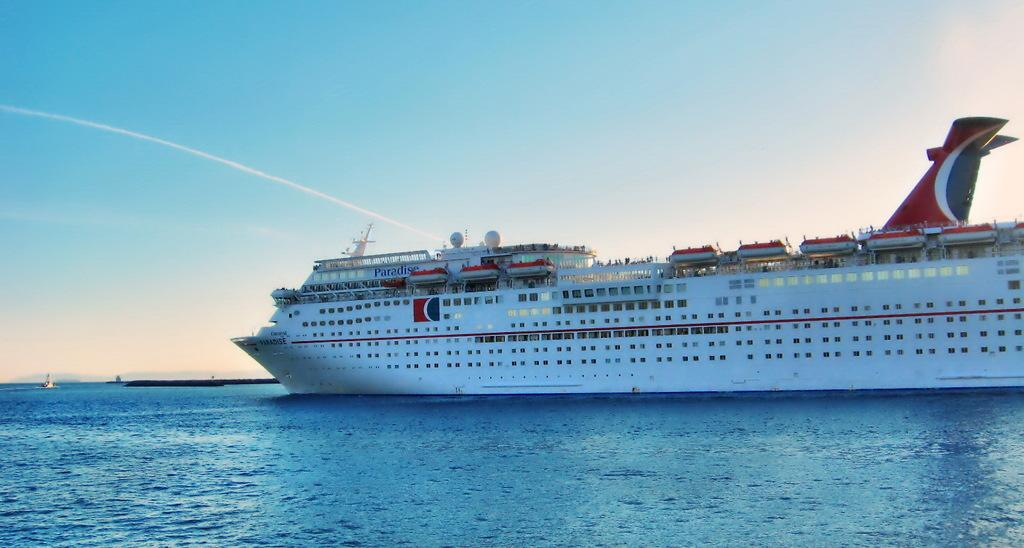<image>
Give a short and clear explanation of the subsequent image. A cruise ship named Paradise has passengers standing on the top deck. 